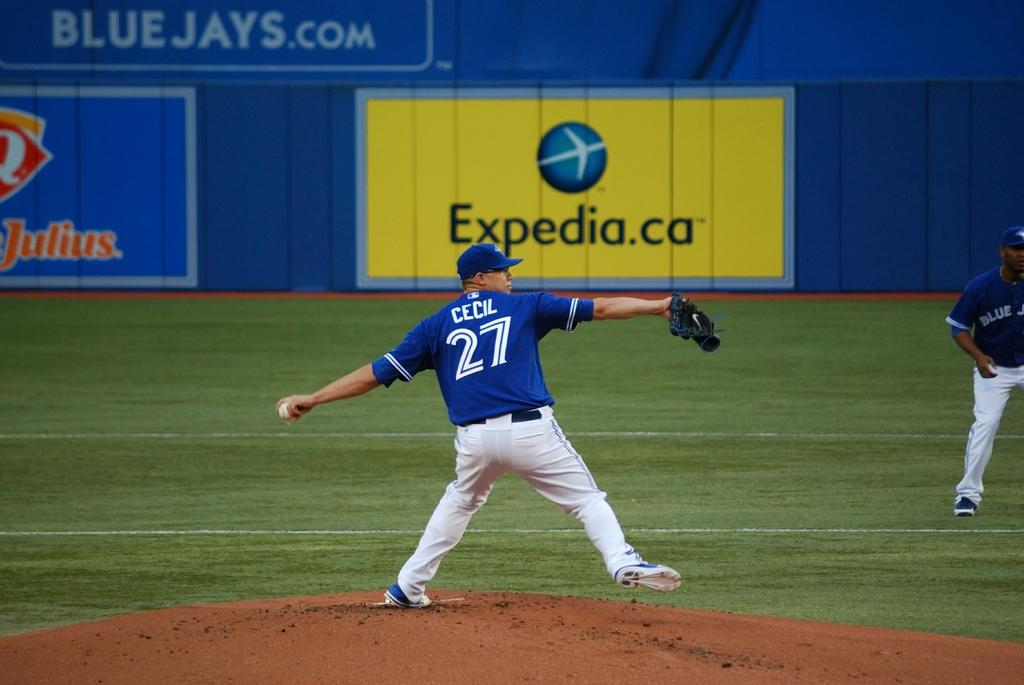Provide a one-sentence caption for the provided image. A man pitching a baseball with an Expedia ad behind him. 